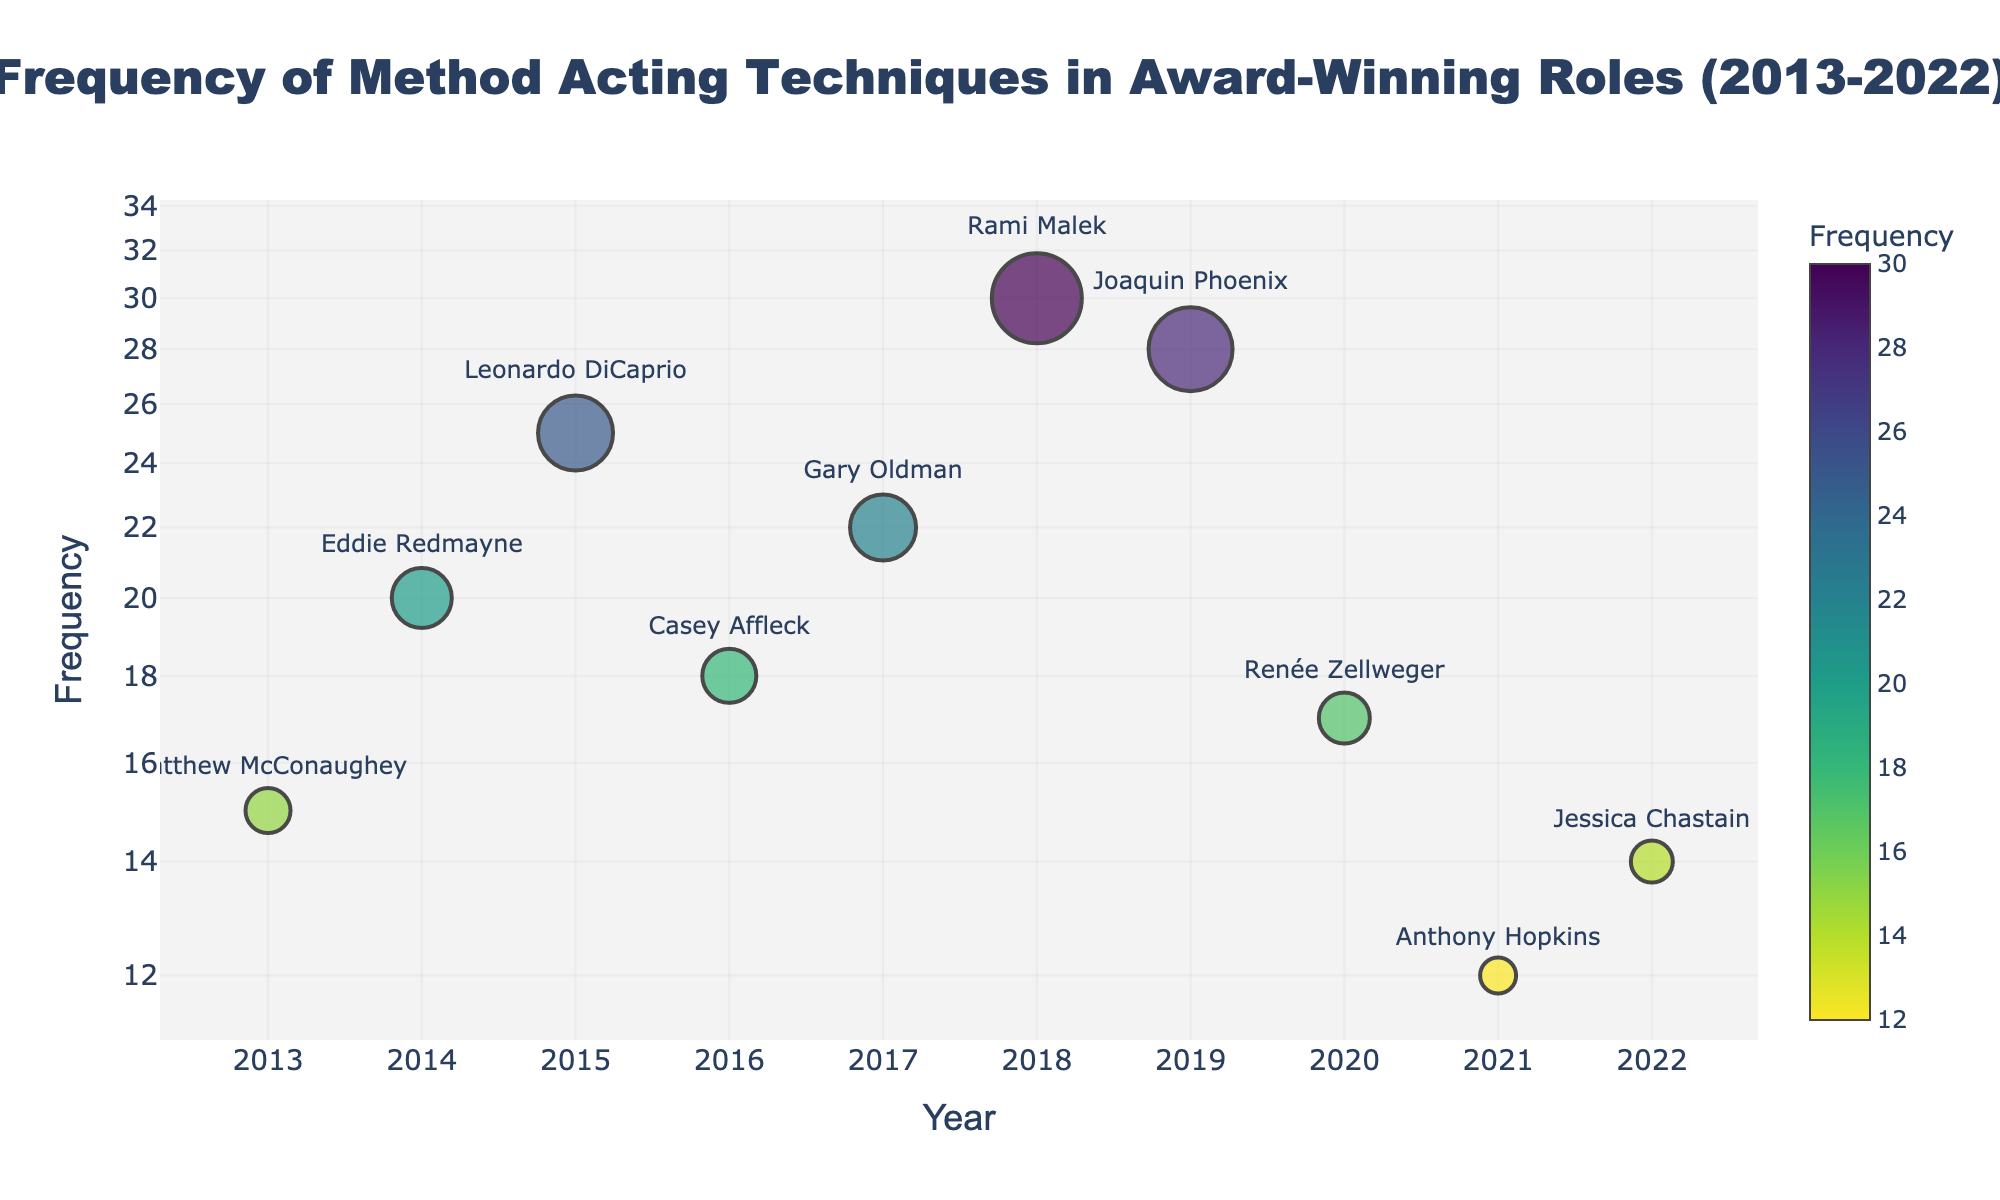Who is the actor with the highest frequency of method acting technique usage in the figure? The actor with the highest frequency can be identified by looking at the largest marker on the vertical axis. The name associated with the largest marker is what we seek.
Answer: Rami Malek In what year was 'Physical Transformation' used the most frequently in award-winning roles? By finding the year associated with the highest frequency for 'Physical Transformation' on the vertical axis, you can determine the respective year.
Answer: 2014 What is the median frequency of method acting techniques used across the given years? To find the median, list all the frequencies in ascending order: 12, 14, 15, 17, 18, 20, 22, 25, 28, 30; the middle value(s) are 18 and 20, so the median is the average of these two values ((18+20)/2).
Answer: 19 Which actor used the 'Weight Loss and Physical Transformation' technique and what was the frequency? By referring to the hover information and names associated with each marker, identify the actor and frequency related to 'Weight Loss and Physical Transformation'.
Answer: Joaquin Phoenix, 28 How does the frequency of method acting techniques in 2017 compare to that in 2022? Determine the frequencies for the given years from the markers and compare the values.
Answer: Higher in 2017 Which method acting technique saw the least frequency of use and in what year? By finding the smallest marker on the vertical axis and noting the year and related acting technique from the hover information, identify the answer.
Answer: Memory Immersion, 2021 What is the range of the frequencies observed across all years? The range is calculated by taking the difference between the maximum (30) and minimum (12) frequencies.
Answer: 18 Which year had the most variation in method acting technique frequencies? To determine the year with the most variation, observe the markers' spread on the vertical axis and find the year with the most distant points.
Answer: 2019 In what year did twice as much frequency happen compared to 2013, and who was the actor associated with that frequency? By identifying the frequency for 2013 (15), look for the year where the frequency was approximately twice that (2*15=30) and identify the associated actor.
Answer: 2018, Rami Malek How many different method acting techniques were used by the actors mentioned in the figure? Count the distinct method acting techniques listed in the data provided and depicted in the hover information for each marker.
Answer: 10 